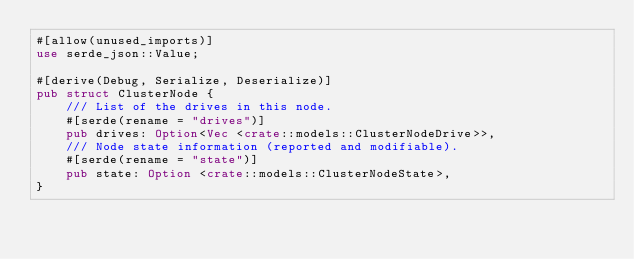Convert code to text. <code><loc_0><loc_0><loc_500><loc_500><_Rust_>#[allow(unused_imports)]
use serde_json::Value;

#[derive(Debug, Serialize, Deserialize)]
pub struct ClusterNode {
    /// List of the drives in this node.
    #[serde(rename = "drives")]
    pub drives: Option<Vec <crate::models::ClusterNodeDrive>>,
    /// Node state information (reported and modifiable).
    #[serde(rename = "state")]
    pub state: Option <crate::models::ClusterNodeState>,
}
</code> 